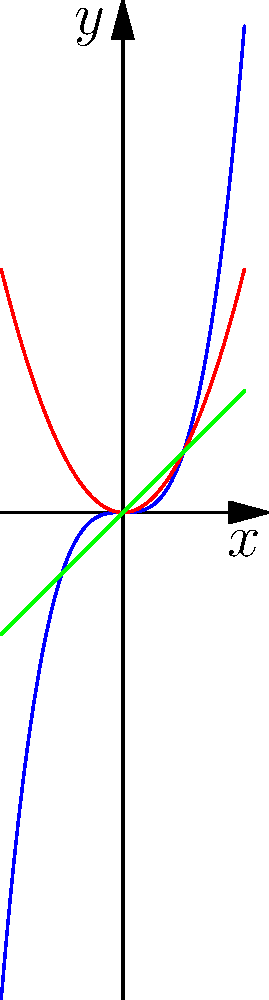As a startup owner looking to understand website traffic growth patterns, you encounter three different models represented by polynomial functions: $f(x)=x^3$, $g(x)=x^2$, and $h(x)=x$. These functions could represent different marketing strategies' impact on site traffic over time. Which function would likely represent the most aggressive growth strategy for increasing site traffic? To determine which function represents the most aggressive growth strategy, we need to analyze the behavior of each polynomial:

1. $h(x)=x$: This is a linear function, representing constant growth. The rate of increase is steady and doesn't accelerate.

2. $g(x)=x^2$: This is a quadratic function. It grows faster than the linear function, especially as x increases. The rate of growth accelerates, but not as rapidly as the cubic function.

3. $f(x)=x^3$: This is a cubic function. It starts slow for small x values but then grows extremely rapidly as x increases. The rate of growth accelerates much faster than both the linear and quadratic functions.

Visually, we can see that the blue curve ($f(x)=x^3$) overtakes the other two curves and rises most steeply in the positive x direction.

In the context of website traffic growth:
- $h(x)=x$ might represent a steady, consistent marketing effort.
- $g(x)=x^2$ could represent a more dynamic strategy with increasing returns.
- $f(x)=x^3$ likely represents the most aggressive strategy, potentially involving viral marketing or exponential user acquisition tactics.

Therefore, $f(x)=x^3$ represents the most aggressive growth strategy for increasing site traffic.
Answer: $f(x)=x^3$ 